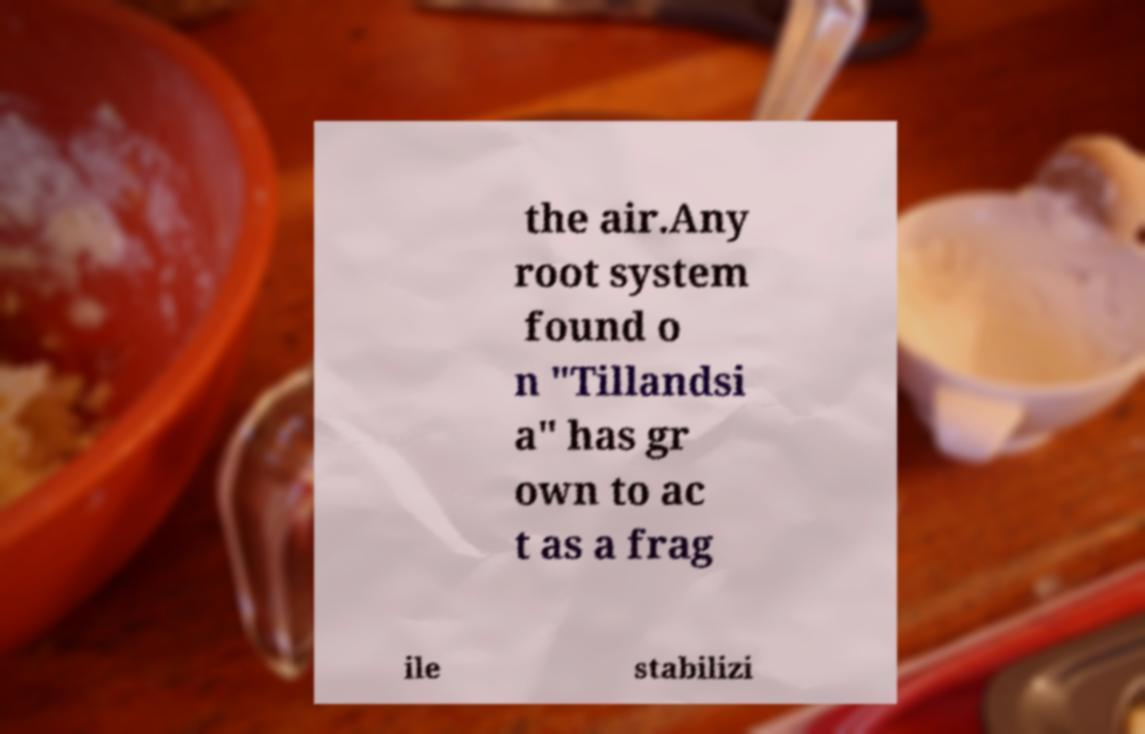Please identify and transcribe the text found in this image. the air.Any root system found o n "Tillandsi a" has gr own to ac t as a frag ile stabilizi 